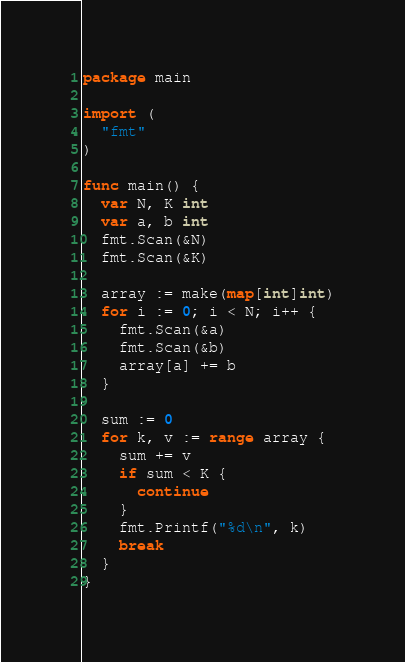Convert code to text. <code><loc_0><loc_0><loc_500><loc_500><_Go_>package main
 
import (
  "fmt"
)
 
func main() {
  var N, K int
  var a, b int
  fmt.Scan(&N)
  fmt.Scan(&K)
  
  array := make(map[int]int)
  for i := 0; i < N; i++ {
    fmt.Scan(&a)
    fmt.Scan(&b)
    array[a] += b
  }
  
  sum := 0
  for k, v := range array {
    sum += v
    if sum < K {
      continue
    }
    fmt.Printf("%d\n", k)
    break
  }
}</code> 